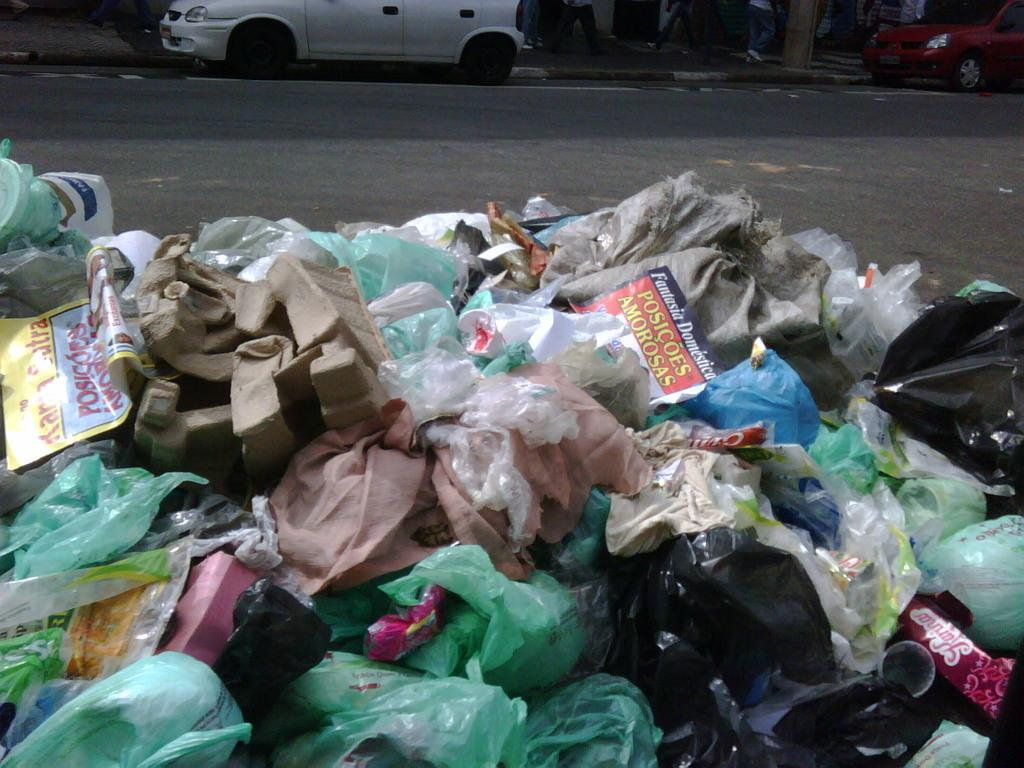What type of objects can be seen in the image? There are plastic covers, posters, and other waste in the image. Where is the waste located in relation to the road? The waste is near a road. What can be seen on the road in the image? There are vehicles parked on the road. How would you describe the background of the image? The background of the image is dark in color. What type of jelly can be seen on the posters in the image? There is no jelly present on the posters or anywhere else in the image. Is there a crook trying to steal the plastic covers in the image? There is no crook or any indication of theft in the image; it simply shows waste near a road. 